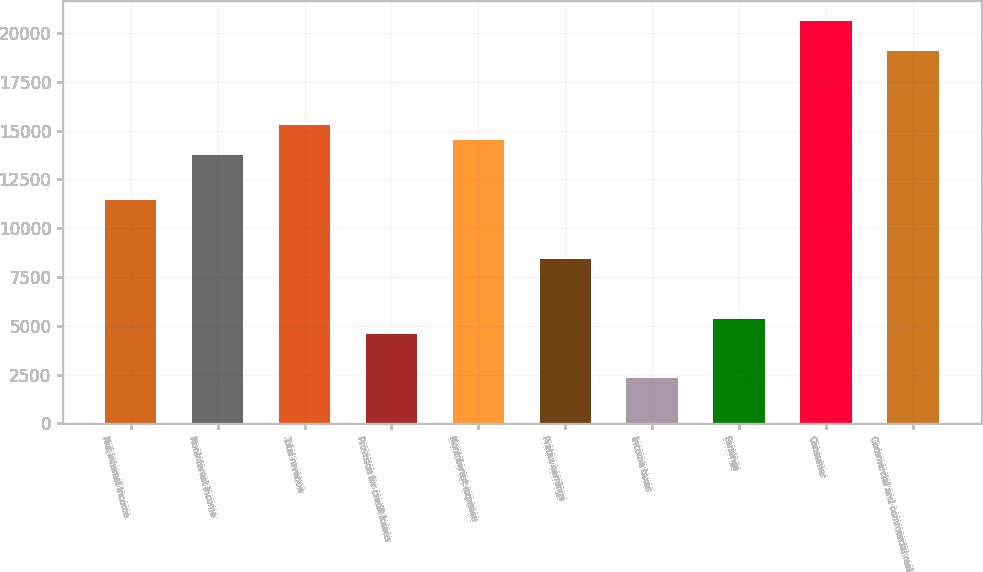<chart> <loc_0><loc_0><loc_500><loc_500><bar_chart><fcel>Net interest income<fcel>Noninterest income<fcel>Total revenue<fcel>Provision for credit losses<fcel>Noninterest expense<fcel>Pretax earnings<fcel>Income taxes<fcel>Earnings<fcel>Consumer<fcel>Commercial and commercial real<nl><fcel>11455.5<fcel>13743<fcel>15268<fcel>4593<fcel>14505.5<fcel>8405.5<fcel>2305.5<fcel>5355.5<fcel>20605.5<fcel>19080.5<nl></chart> 